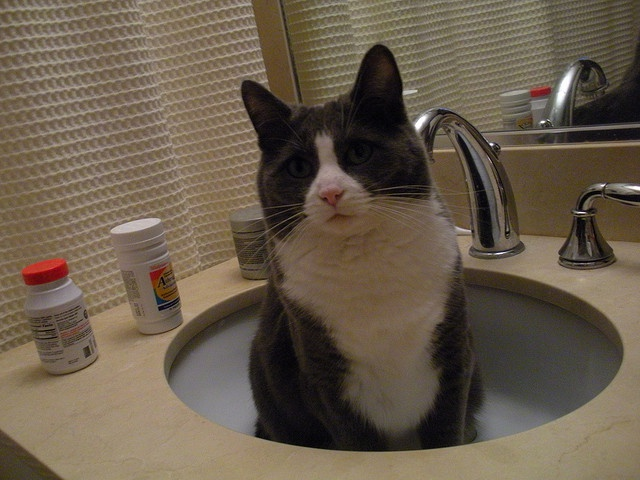Describe the objects in this image and their specific colors. I can see cat in gray and black tones, sink in gray and black tones, bottle in gray and maroon tones, and bottle in gray and maroon tones in this image. 